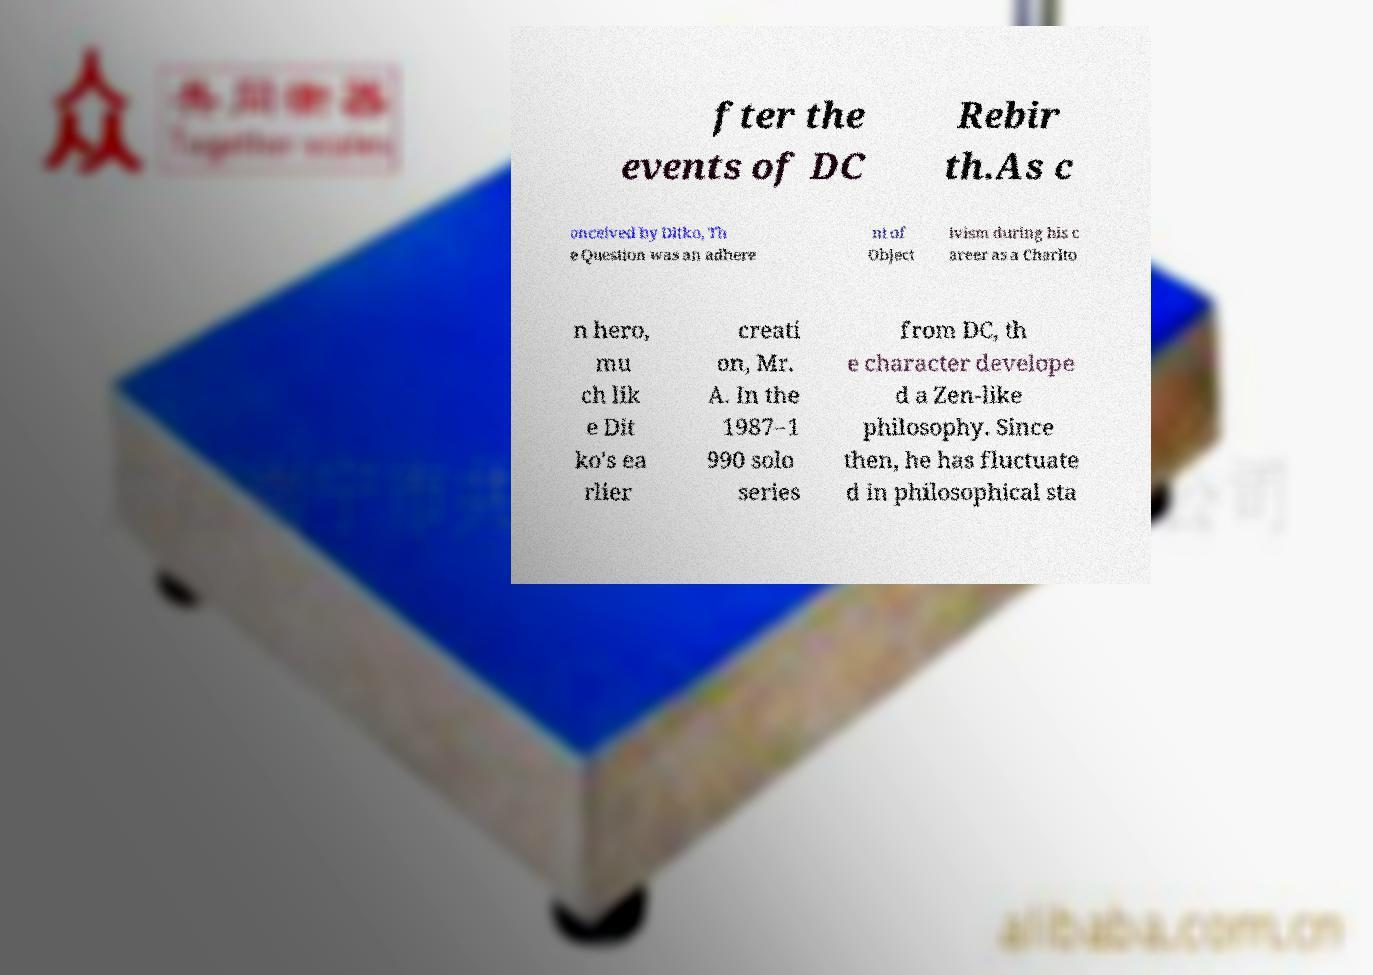There's text embedded in this image that I need extracted. Can you transcribe it verbatim? fter the events of DC Rebir th.As c onceived by Ditko, Th e Question was an adhere nt of Object ivism during his c areer as a Charlto n hero, mu ch lik e Dit ko's ea rlier creati on, Mr. A. In the 1987–1 990 solo series from DC, th e character develope d a Zen-like philosophy. Since then, he has fluctuate d in philosophical sta 